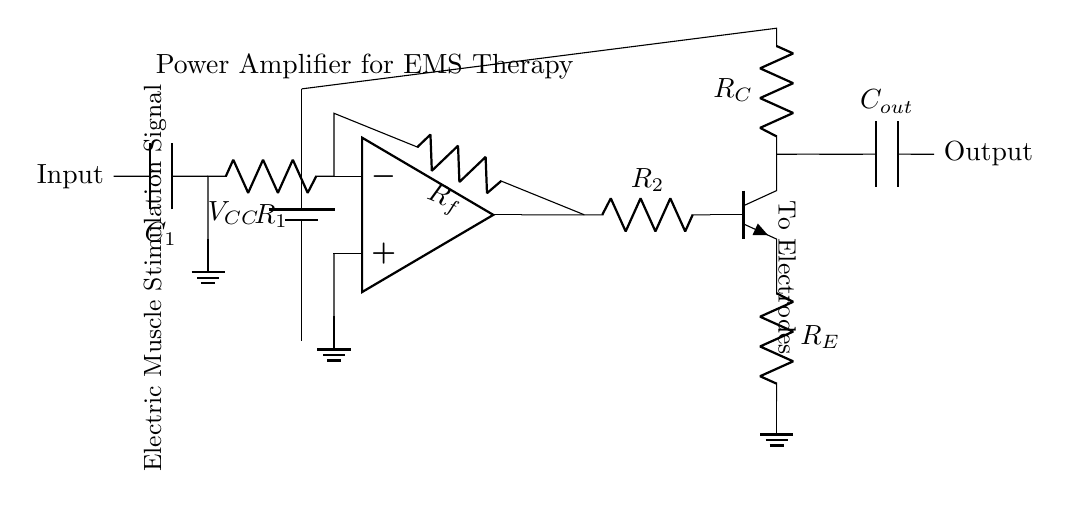What type of amplifier is shown in this diagram? The circuit diagram is identified as a power amplifier, which is indicated by the label "Power Amplifier for EMS Therapy" at the top.
Answer: Power amplifier What is the purpose of resistor R1? Resistor R1 is connected to the inverting terminal of the operational amplifier. It helps set the gain of the amplifier by providing feedback for signal inversion.
Answer: Gain setting What component provides the output signal to electrodes? The output from the collector of the transistor Q1, labeled as "To Electrodes," indicates that this is where the signal exits the amplifier circuit.
Answer: Output capacitor What type of transistor is used in the output stage? The diagram specifies the transistor as an npn type, based on the label seen next to the transistor symbol in the circuit.
Answer: Npn What is the function of capacitor C1 in this circuit? Capacitor C1 connects the input signal to the inverting terminal of the operational amplifier, allowing AC signals to pass while blocking DC components, which aids in amplifying the intended signal.
Answer: AC coupling How does feedback affect the gain of the amplifier? Feedback is provided through resistor Rf, which connects the output from the op-amp back to the inverting input, thereby reducing the gain. The amount of feedback determines how much gain is necessary for the desired output.
Answer: Reduces gain 